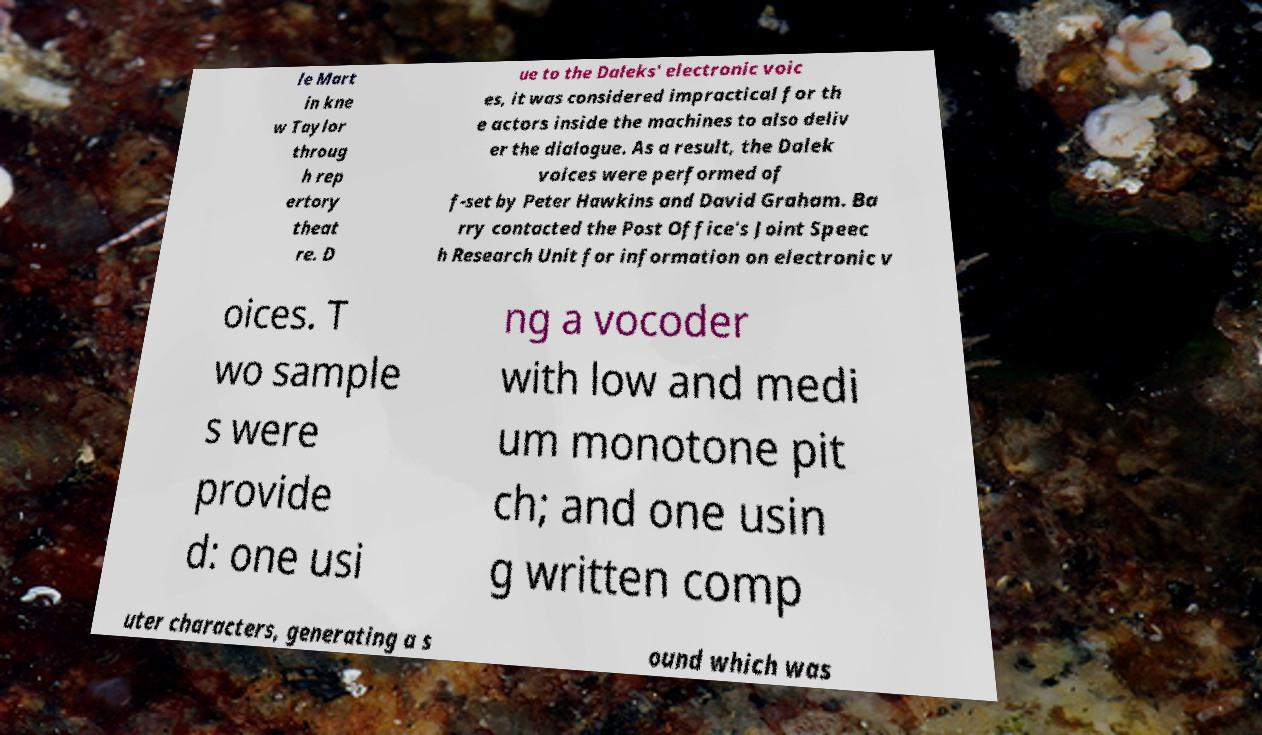Could you assist in decoding the text presented in this image and type it out clearly? le Mart in kne w Taylor throug h rep ertory theat re. D ue to the Daleks' electronic voic es, it was considered impractical for th e actors inside the machines to also deliv er the dialogue. As a result, the Dalek voices were performed of f-set by Peter Hawkins and David Graham. Ba rry contacted the Post Office's Joint Speec h Research Unit for information on electronic v oices. T wo sample s were provide d: one usi ng a vocoder with low and medi um monotone pit ch; and one usin g written comp uter characters, generating a s ound which was 